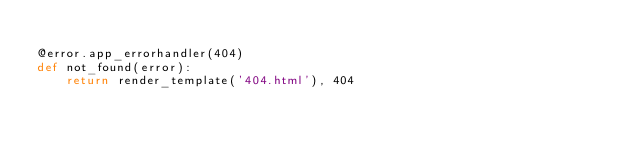<code> <loc_0><loc_0><loc_500><loc_500><_Python_>
@error.app_errorhandler(404)
def not_found(error):
    return render_template('404.html'), 404
</code> 